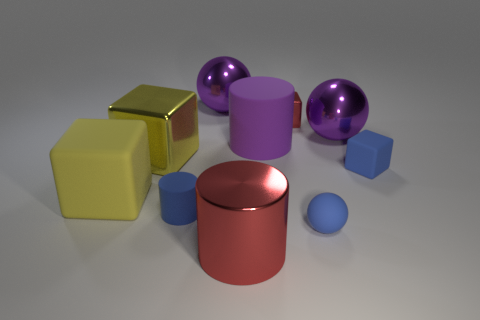Does the rubber object that is in front of the tiny cylinder have the same color as the large matte object that is to the right of the blue rubber cylinder?
Your response must be concise. No. Is there a matte sphere of the same size as the yellow matte cube?
Offer a very short reply. No. What is the big object that is both right of the red cylinder and behind the large matte cylinder made of?
Offer a very short reply. Metal. What number of metallic objects are red cylinders or small red blocks?
Offer a terse response. 2. There is a big red thing that is made of the same material as the red block; what is its shape?
Your answer should be very brief. Cylinder. How many matte things are left of the tiny blue rubber cylinder and in front of the tiny rubber cylinder?
Offer a very short reply. 0. Are there any other things that have the same shape as the purple matte object?
Offer a terse response. Yes. There is a metallic thing that is in front of the small blue block; how big is it?
Ensure brevity in your answer.  Large. What number of other objects are the same color as the big matte cylinder?
Ensure brevity in your answer.  2. There is a big ball to the right of the big shiny ball that is behind the red metal block; what is it made of?
Your answer should be very brief. Metal. 